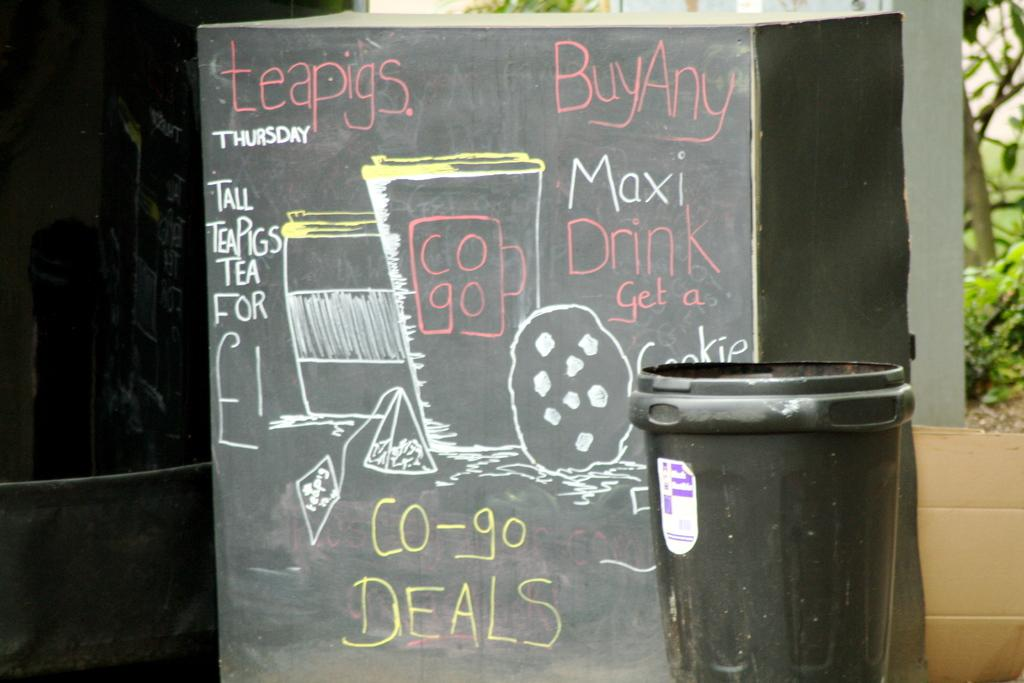<image>
Give a short and clear explanation of the subsequent image. A sign written in pink, white and yellow chalk advertising co-go deals. 